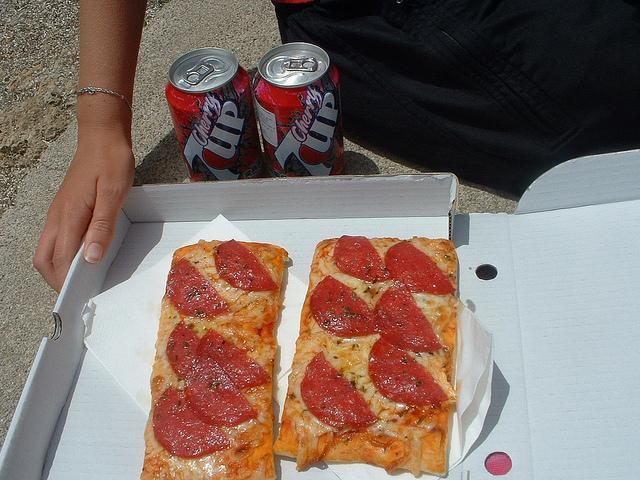How many little pizzas are there?
Give a very brief answer. 2. How many slices of pizza are shown?
Give a very brief answer. 2. 